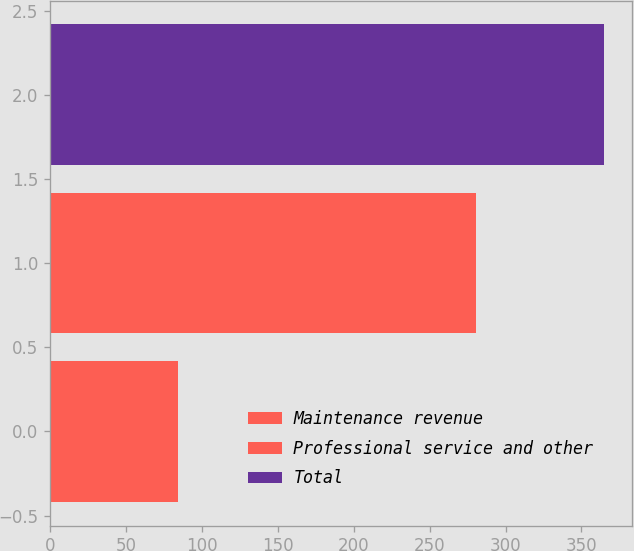<chart> <loc_0><loc_0><loc_500><loc_500><bar_chart><fcel>Maintenance revenue<fcel>Professional service and other<fcel>Total<nl><fcel>84.1<fcel>280.8<fcel>364.9<nl></chart> 